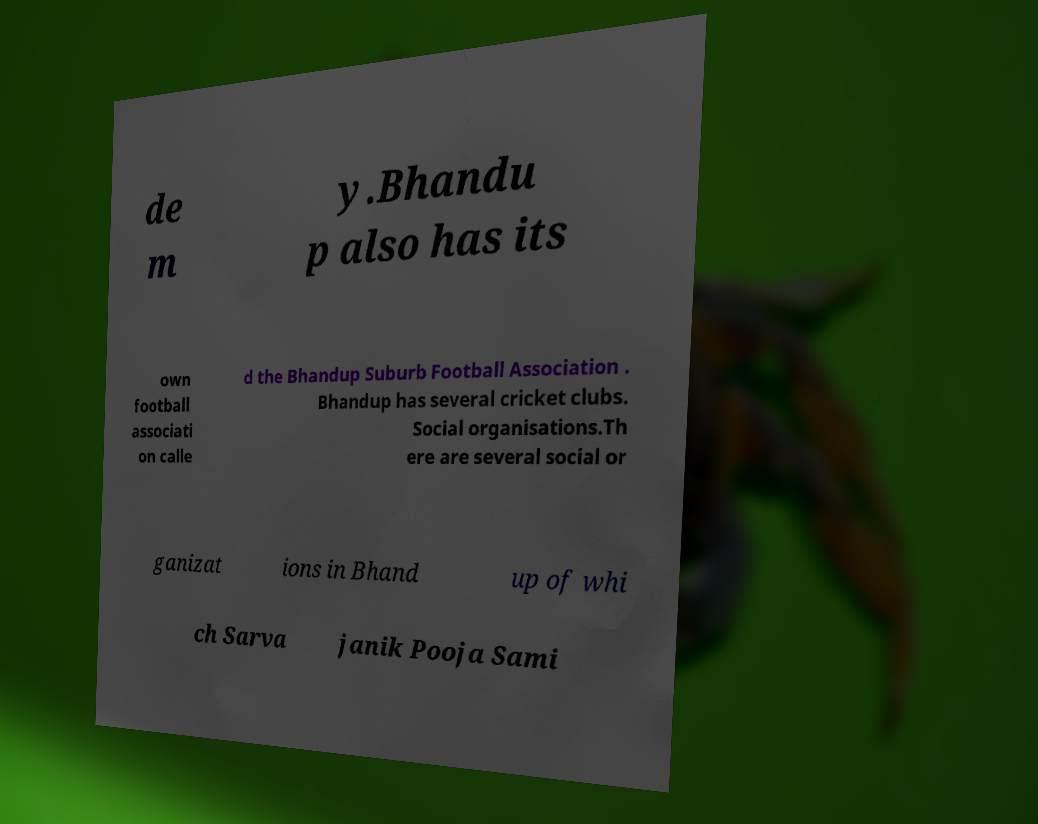There's text embedded in this image that I need extracted. Can you transcribe it verbatim? de m y.Bhandu p also has its own football associati on calle d the Bhandup Suburb Football Association . Bhandup has several cricket clubs. Social organisations.Th ere are several social or ganizat ions in Bhand up of whi ch Sarva janik Pooja Sami 